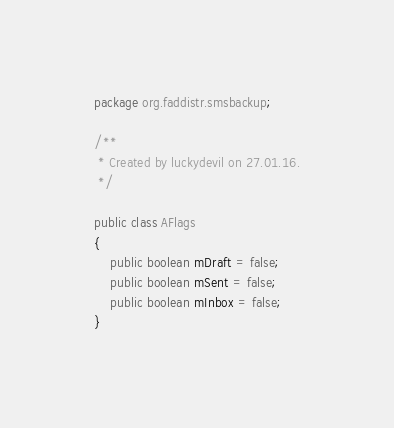Convert code to text. <code><loc_0><loc_0><loc_500><loc_500><_Java_>package org.faddistr.smsbackup;

/**
 * Created by luckydevil on 27.01.16.
 */

public class AFlags
{
    public boolean mDraft = false;
    public boolean mSent = false;
    public boolean mInbox = false;
}
</code> 